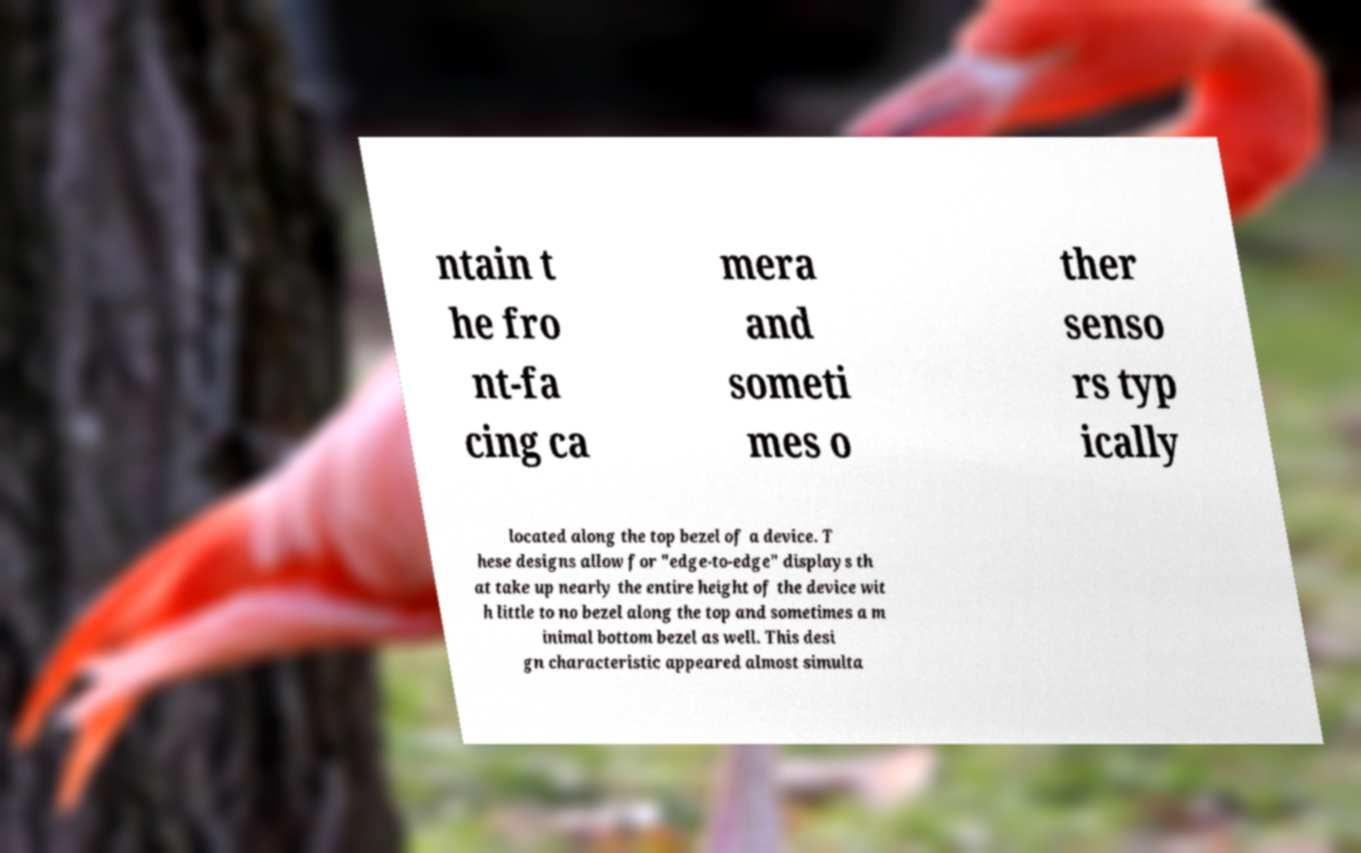Could you extract and type out the text from this image? ntain t he fro nt-fa cing ca mera and someti mes o ther senso rs typ ically located along the top bezel of a device. T hese designs allow for "edge-to-edge" displays th at take up nearly the entire height of the device wit h little to no bezel along the top and sometimes a m inimal bottom bezel as well. This desi gn characteristic appeared almost simulta 